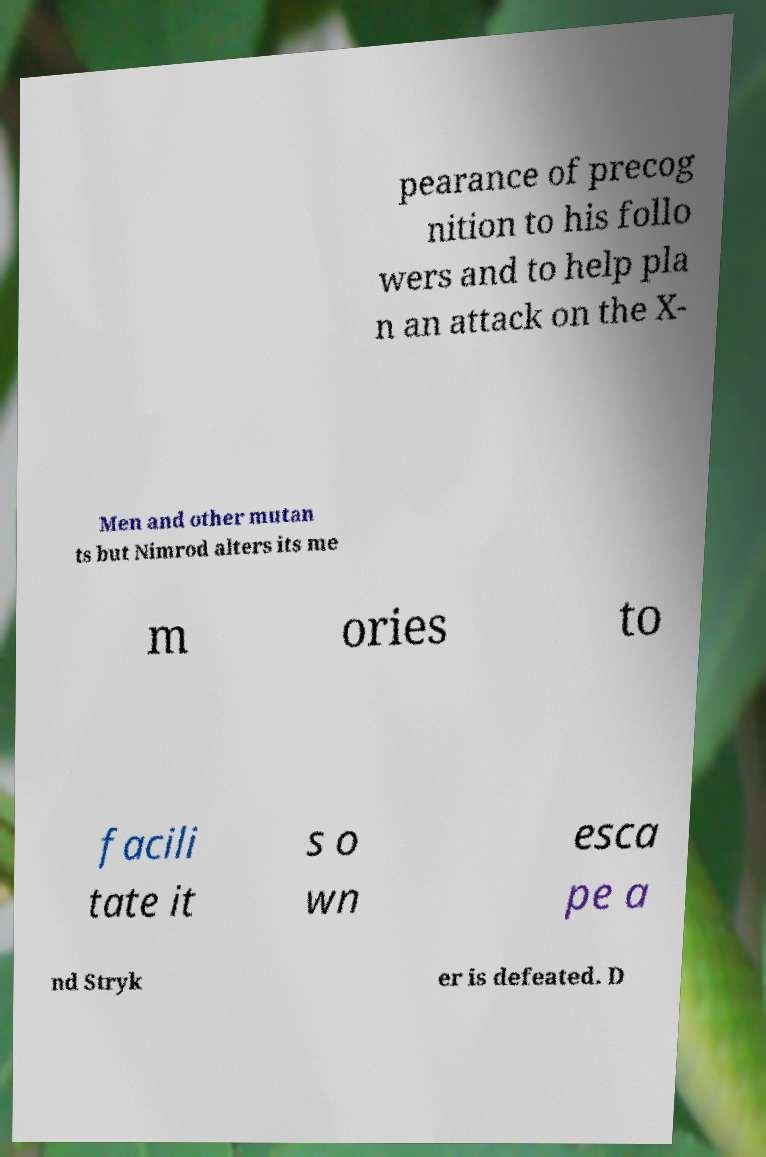For documentation purposes, I need the text within this image transcribed. Could you provide that? pearance of precog nition to his follo wers and to help pla n an attack on the X- Men and other mutan ts but Nimrod alters its me m ories to facili tate it s o wn esca pe a nd Stryk er is defeated. D 